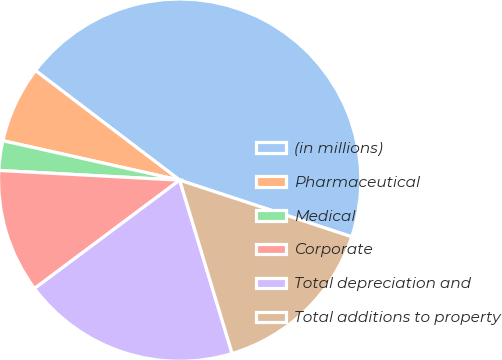Convert chart to OTSL. <chart><loc_0><loc_0><loc_500><loc_500><pie_chart><fcel>(in millions)<fcel>Pharmaceutical<fcel>Medical<fcel>Corporate<fcel>Total depreciation and<fcel>Total additions to property<nl><fcel>44.72%<fcel>6.85%<fcel>2.64%<fcel>11.06%<fcel>19.47%<fcel>15.26%<nl></chart> 